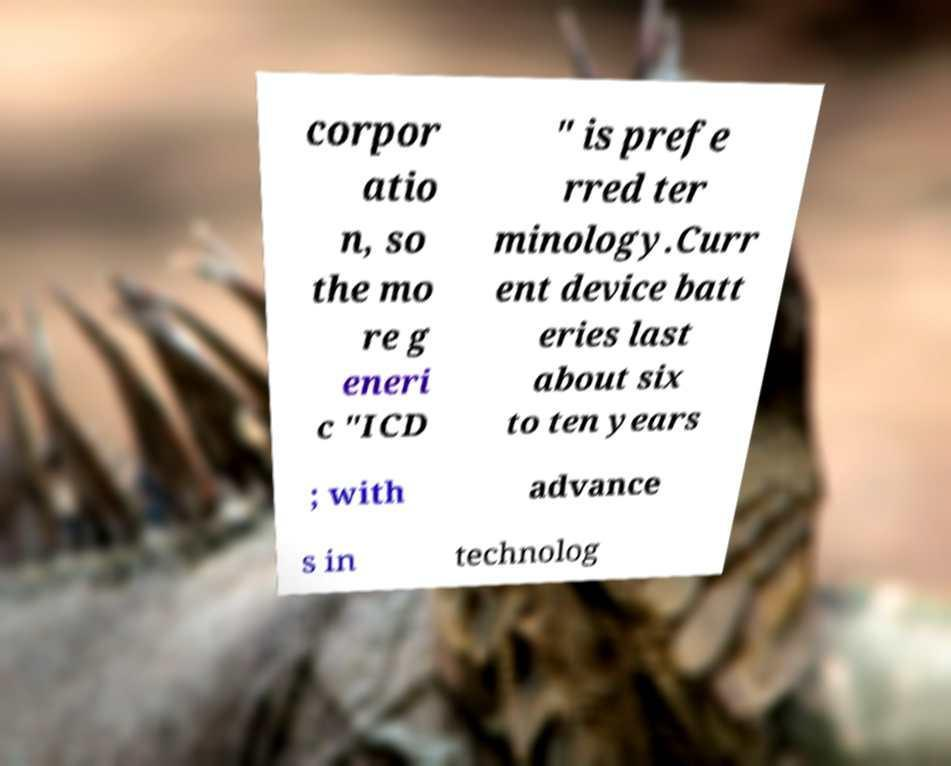Can you read and provide the text displayed in the image?This photo seems to have some interesting text. Can you extract and type it out for me? corpor atio n, so the mo re g eneri c "ICD " is prefe rred ter minology.Curr ent device batt eries last about six to ten years ; with advance s in technolog 